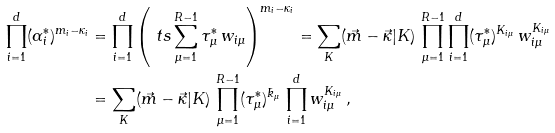Convert formula to latex. <formula><loc_0><loc_0><loc_500><loc_500>\prod _ { i = 1 } ^ { d } ( \alpha _ { i } ^ { * } ) ^ { m _ { i } - \kappa _ { i } } & = \prod _ { i = 1 } ^ { d } \left ( \ t s \sum _ { \mu = 1 } ^ { R - 1 } \tau _ { \mu } ^ { * } \, w _ { i \mu } \right ) ^ { m _ { i } - \kappa _ { i } } = \sum _ { K } ( \vec { m } - \vec { \kappa } | K ) \, \prod _ { \mu = 1 } ^ { R - 1 } \prod _ { i = 1 } ^ { d } ( \tau _ { \mu } ^ { * } ) ^ { K _ { i \mu } } \, w _ { i \mu } ^ { K _ { i \mu } } \\ & = \sum _ { K } ( \vec { m } - \vec { \kappa } | K ) \, \prod _ { \mu = 1 } ^ { R - 1 } ( \tau _ { \mu } ^ { * } ) ^ { \bar { k } _ { \mu } } \, \prod _ { i = 1 } ^ { d } w _ { i \mu } ^ { K _ { i \mu } } \, ,</formula> 